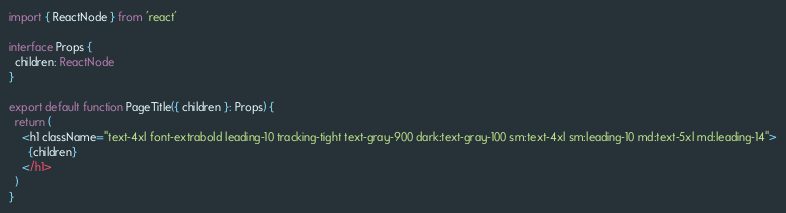Convert code to text. <code><loc_0><loc_0><loc_500><loc_500><_TypeScript_>import { ReactNode } from 'react'

interface Props {
  children: ReactNode
}

export default function PageTitle({ children }: Props) {
  return (
    <h1 className="text-4xl font-extrabold leading-10 tracking-tight text-gray-900 dark:text-gray-100 sm:text-4xl sm:leading-10 md:text-5xl md:leading-14">
      {children}
    </h1>
  )
}
</code> 